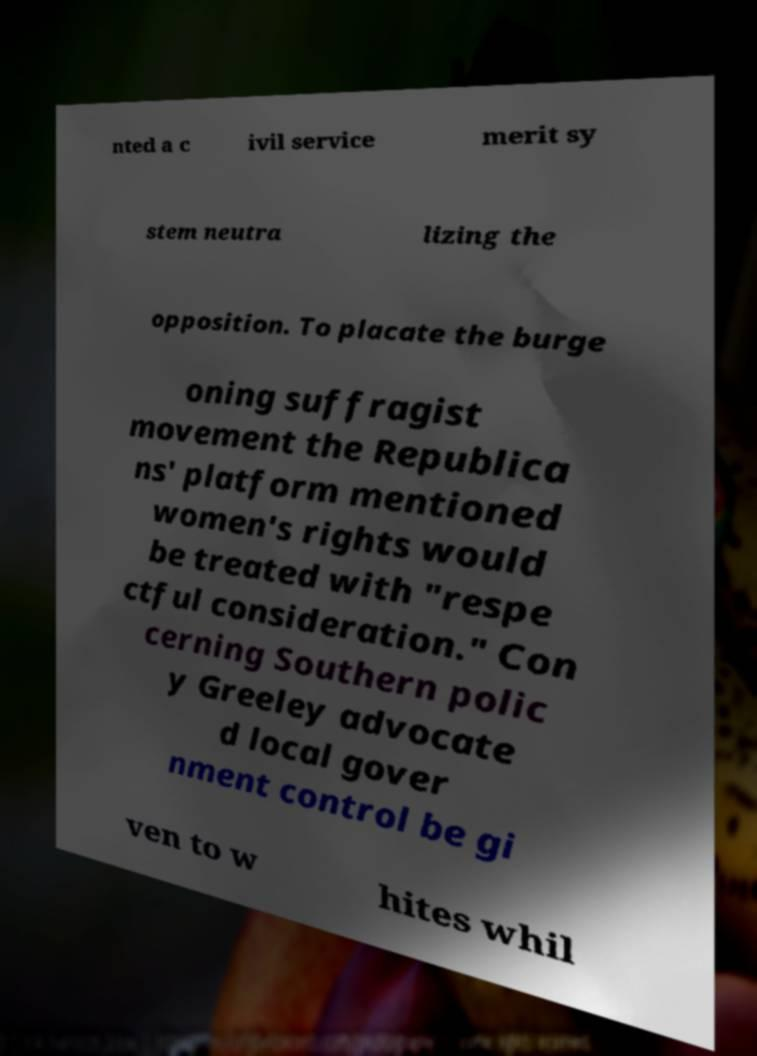Could you extract and type out the text from this image? nted a c ivil service merit sy stem neutra lizing the opposition. To placate the burge oning suffragist movement the Republica ns' platform mentioned women's rights would be treated with "respe ctful consideration." Con cerning Southern polic y Greeley advocate d local gover nment control be gi ven to w hites whil 